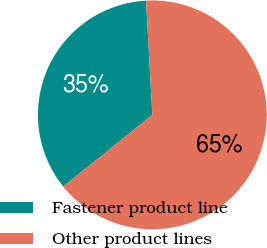<chart> <loc_0><loc_0><loc_500><loc_500><pie_chart><fcel>Fastener product line<fcel>Other product lines<nl><fcel>34.9%<fcel>65.1%<nl></chart> 